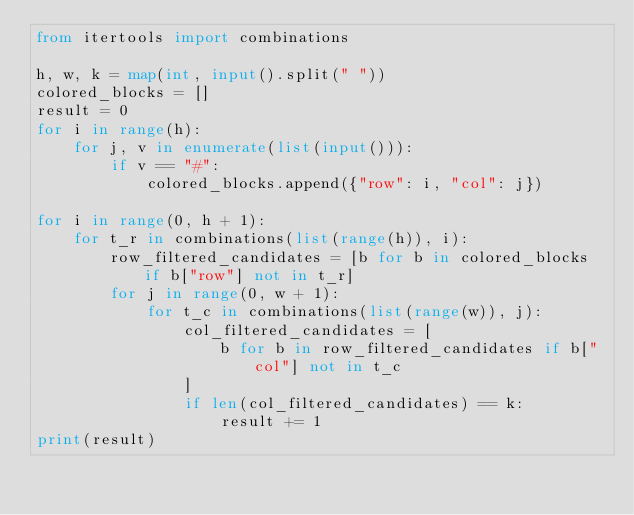Convert code to text. <code><loc_0><loc_0><loc_500><loc_500><_Python_>from itertools import combinations

h, w, k = map(int, input().split(" "))
colored_blocks = []
result = 0
for i in range(h):
    for j, v in enumerate(list(input())):
        if v == "#":
            colored_blocks.append({"row": i, "col": j})

for i in range(0, h + 1):
    for t_r in combinations(list(range(h)), i):
        row_filtered_candidates = [b for b in colored_blocks if b["row"] not in t_r]
        for j in range(0, w + 1):
            for t_c in combinations(list(range(w)), j):
                col_filtered_candidates = [
                    b for b in row_filtered_candidates if b["col"] not in t_c
                ]
                if len(col_filtered_candidates) == k:
                    result += 1
print(result)</code> 